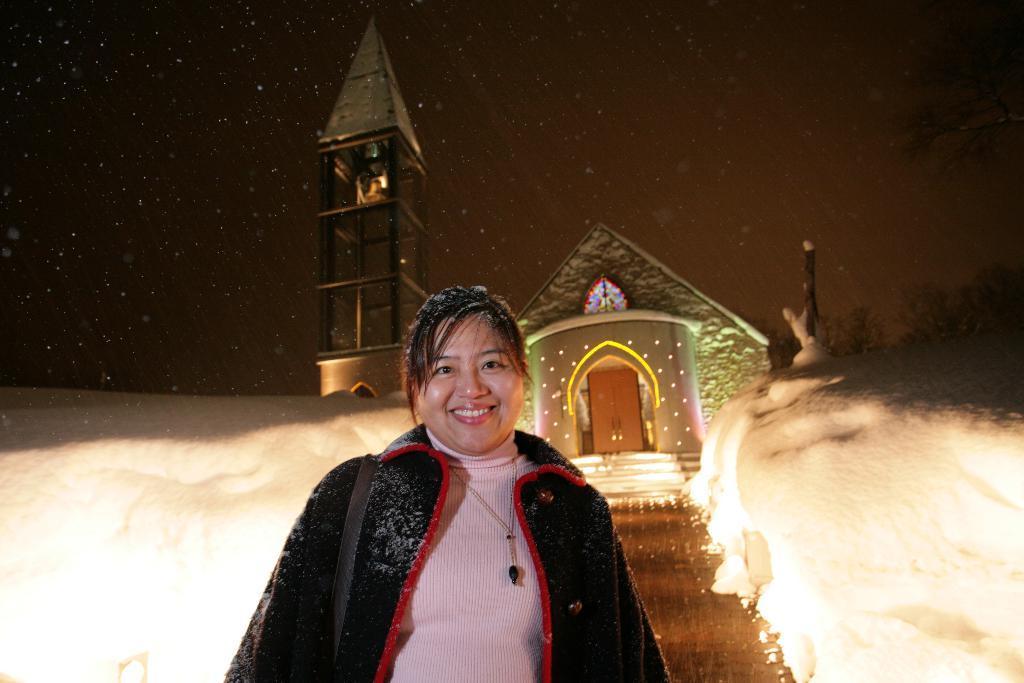In one or two sentences, can you explain what this image depicts? In the image a woman is standing and smiling. Behind her there is snow and house. At the top of the image there are some stars and sky. 